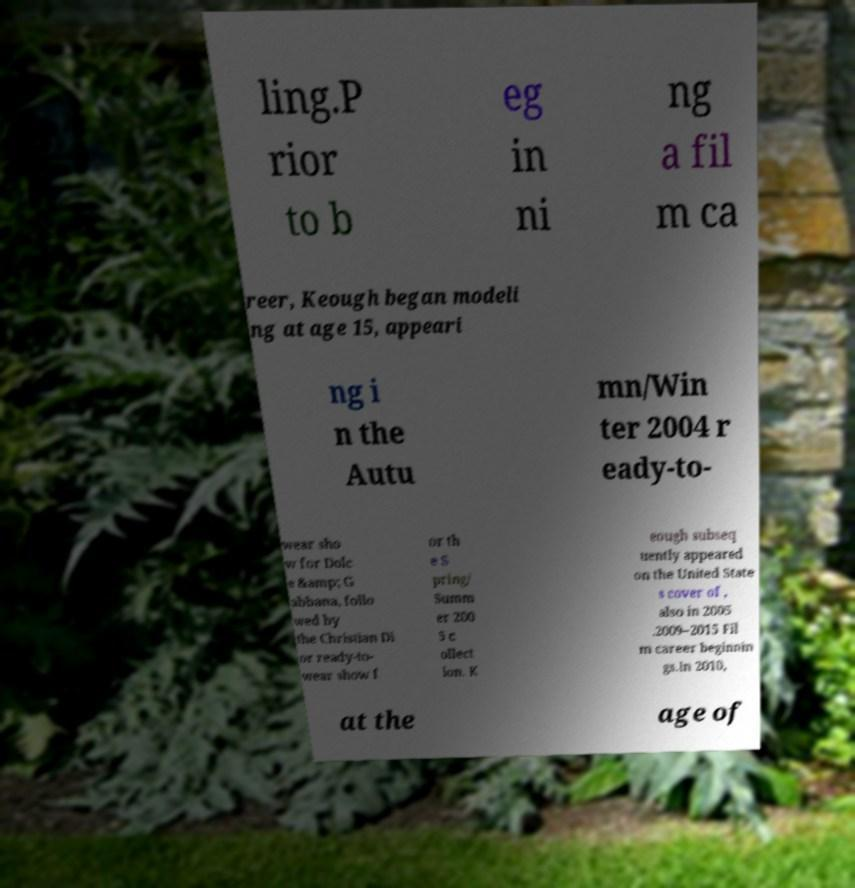Can you read and provide the text displayed in the image?This photo seems to have some interesting text. Can you extract and type it out for me? ling.P rior to b eg in ni ng a fil m ca reer, Keough began modeli ng at age 15, appeari ng i n the Autu mn/Win ter 2004 r eady-to- wear sho w for Dolc e &amp; G abbana, follo wed by the Christian Di or ready-to- wear show f or th e S pring/ Summ er 200 5 c ollect ion. K eough subseq uently appeared on the United State s cover of , also in 2005 .2009–2015 Fil m career beginnin gs.In 2010, at the age of 